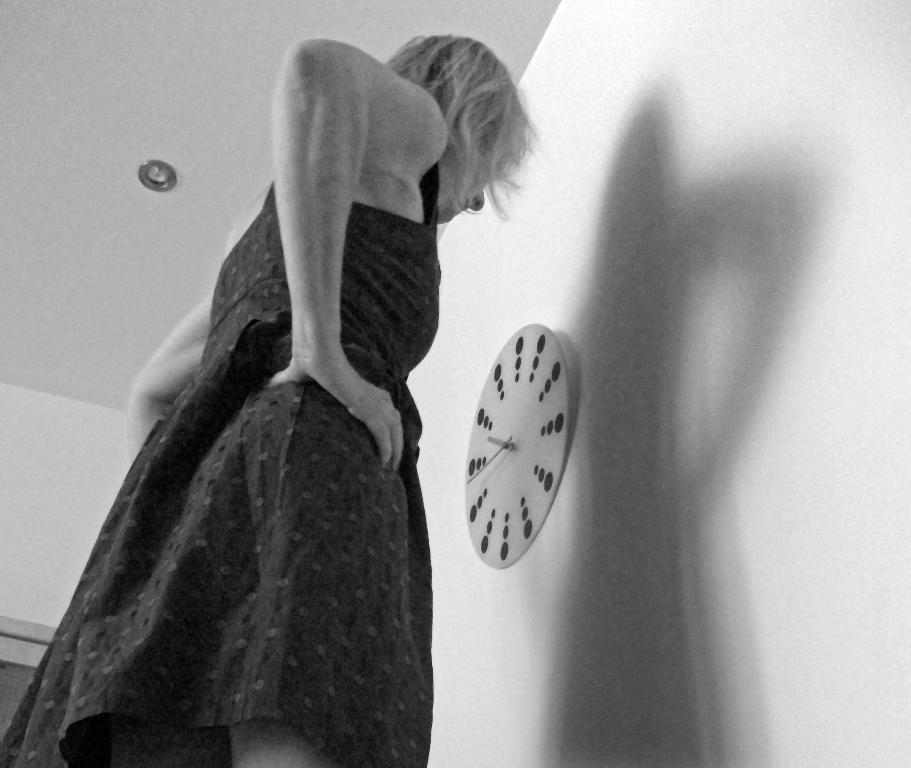What is the main subject in the image? There is a woman standing in the image. Can you describe any objects in the background? There is a clock on the wall in the image. How many nets are visible in the image? There are no nets visible in the image. What type of truck can be seen in the image? There is no truck present in the image. 